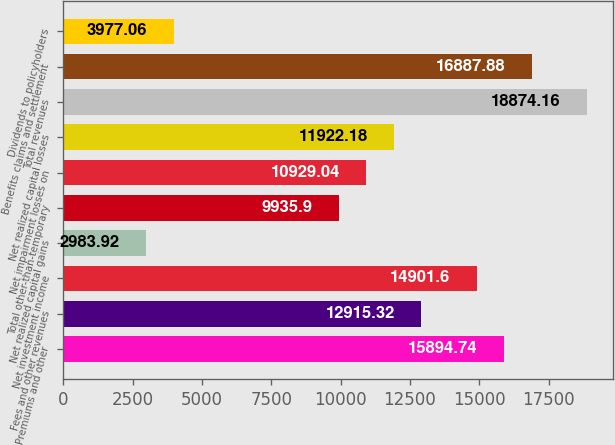Convert chart to OTSL. <chart><loc_0><loc_0><loc_500><loc_500><bar_chart><fcel>Premiums and other<fcel>Fees and other revenues<fcel>Net investment income<fcel>Net realized capital gains<fcel>Total other-than-temporary<fcel>Net impairment losses on<fcel>Net realized capital losses<fcel>Total revenues<fcel>Benefits claims and settlement<fcel>Dividends to policyholders<nl><fcel>15894.7<fcel>12915.3<fcel>14901.6<fcel>2983.92<fcel>9935.9<fcel>10929<fcel>11922.2<fcel>18874.2<fcel>16887.9<fcel>3977.06<nl></chart> 